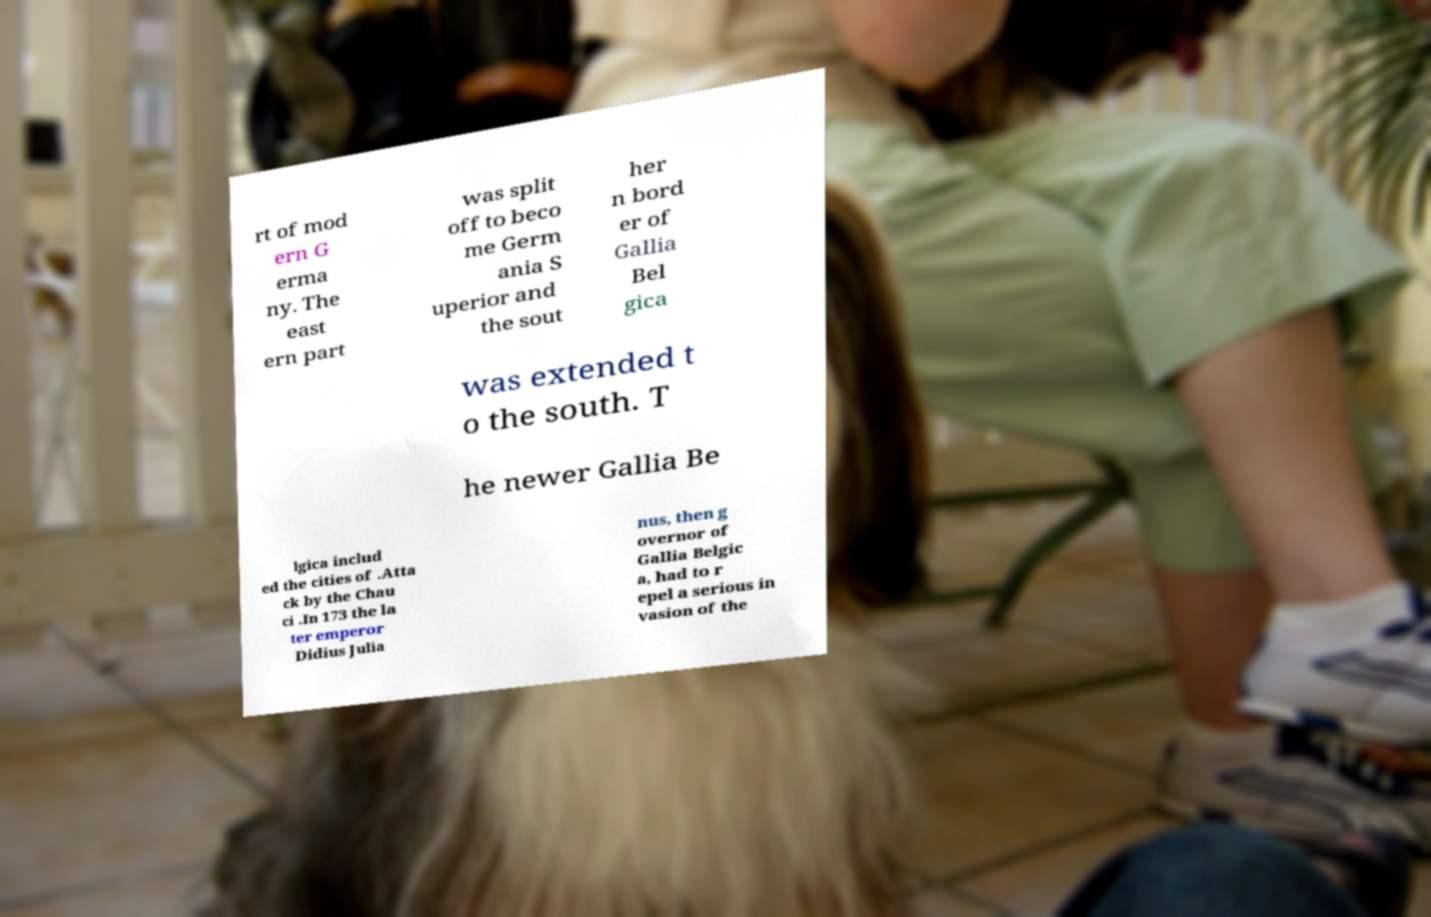I need the written content from this picture converted into text. Can you do that? rt of mod ern G erma ny. The east ern part was split off to beco me Germ ania S uperior and the sout her n bord er of Gallia Bel gica was extended t o the south. T he newer Gallia Be lgica includ ed the cities of .Atta ck by the Chau ci .In 173 the la ter emperor Didius Julia nus, then g overnor of Gallia Belgic a, had to r epel a serious in vasion of the 